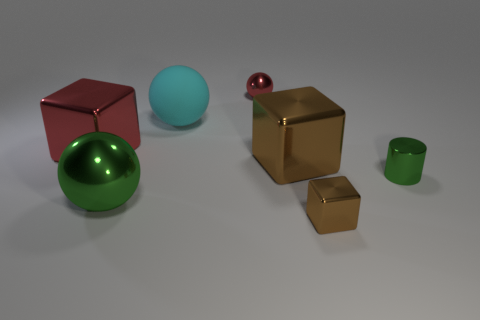Add 2 big cubes. How many objects exist? 9 Subtract all spheres. How many objects are left? 4 Subtract all big cyan balls. Subtract all big brown rubber cylinders. How many objects are left? 6 Add 5 red objects. How many red objects are left? 7 Add 3 small red spheres. How many small red spheres exist? 4 Subtract 0 yellow cylinders. How many objects are left? 7 